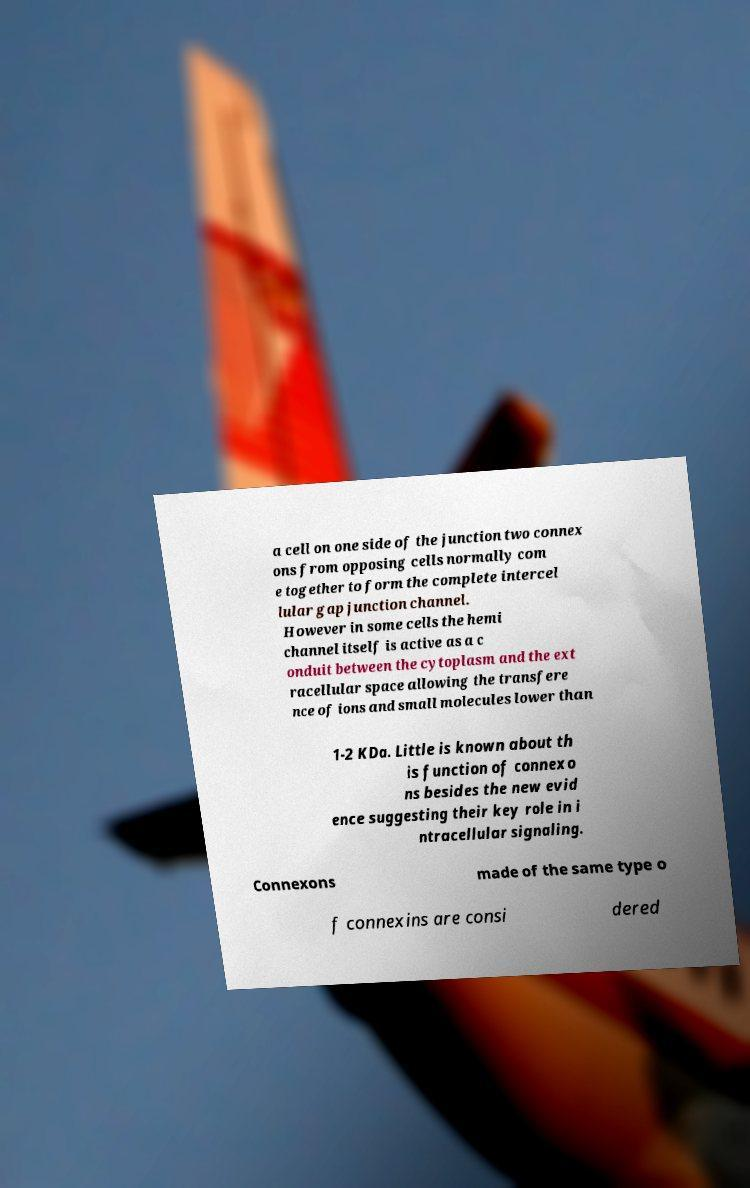For documentation purposes, I need the text within this image transcribed. Could you provide that? a cell on one side of the junction two connex ons from opposing cells normally com e together to form the complete intercel lular gap junction channel. However in some cells the hemi channel itself is active as a c onduit between the cytoplasm and the ext racellular space allowing the transfere nce of ions and small molecules lower than 1-2 KDa. Little is known about th is function of connexo ns besides the new evid ence suggesting their key role in i ntracellular signaling. Connexons made of the same type o f connexins are consi dered 